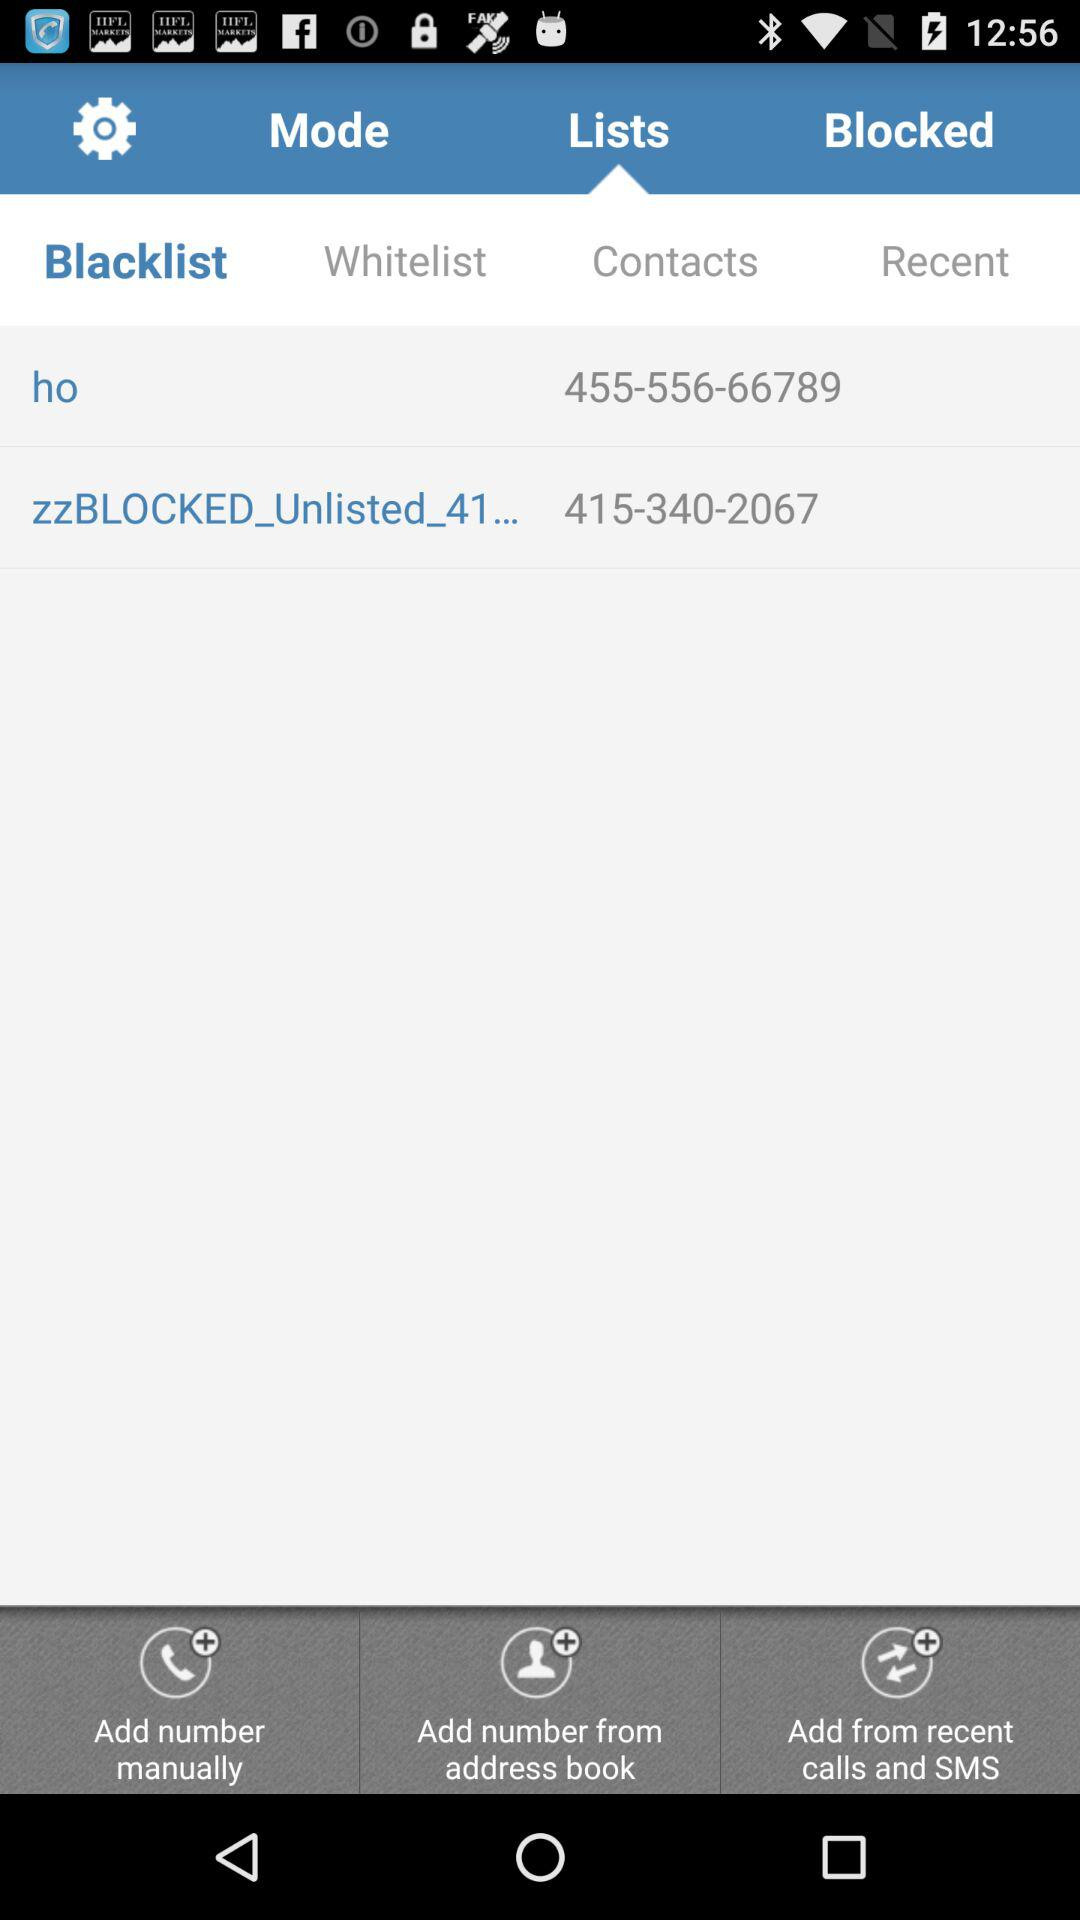Which tab has been selected? The tabs that have been selected are "Lists" and "Blacklist". 